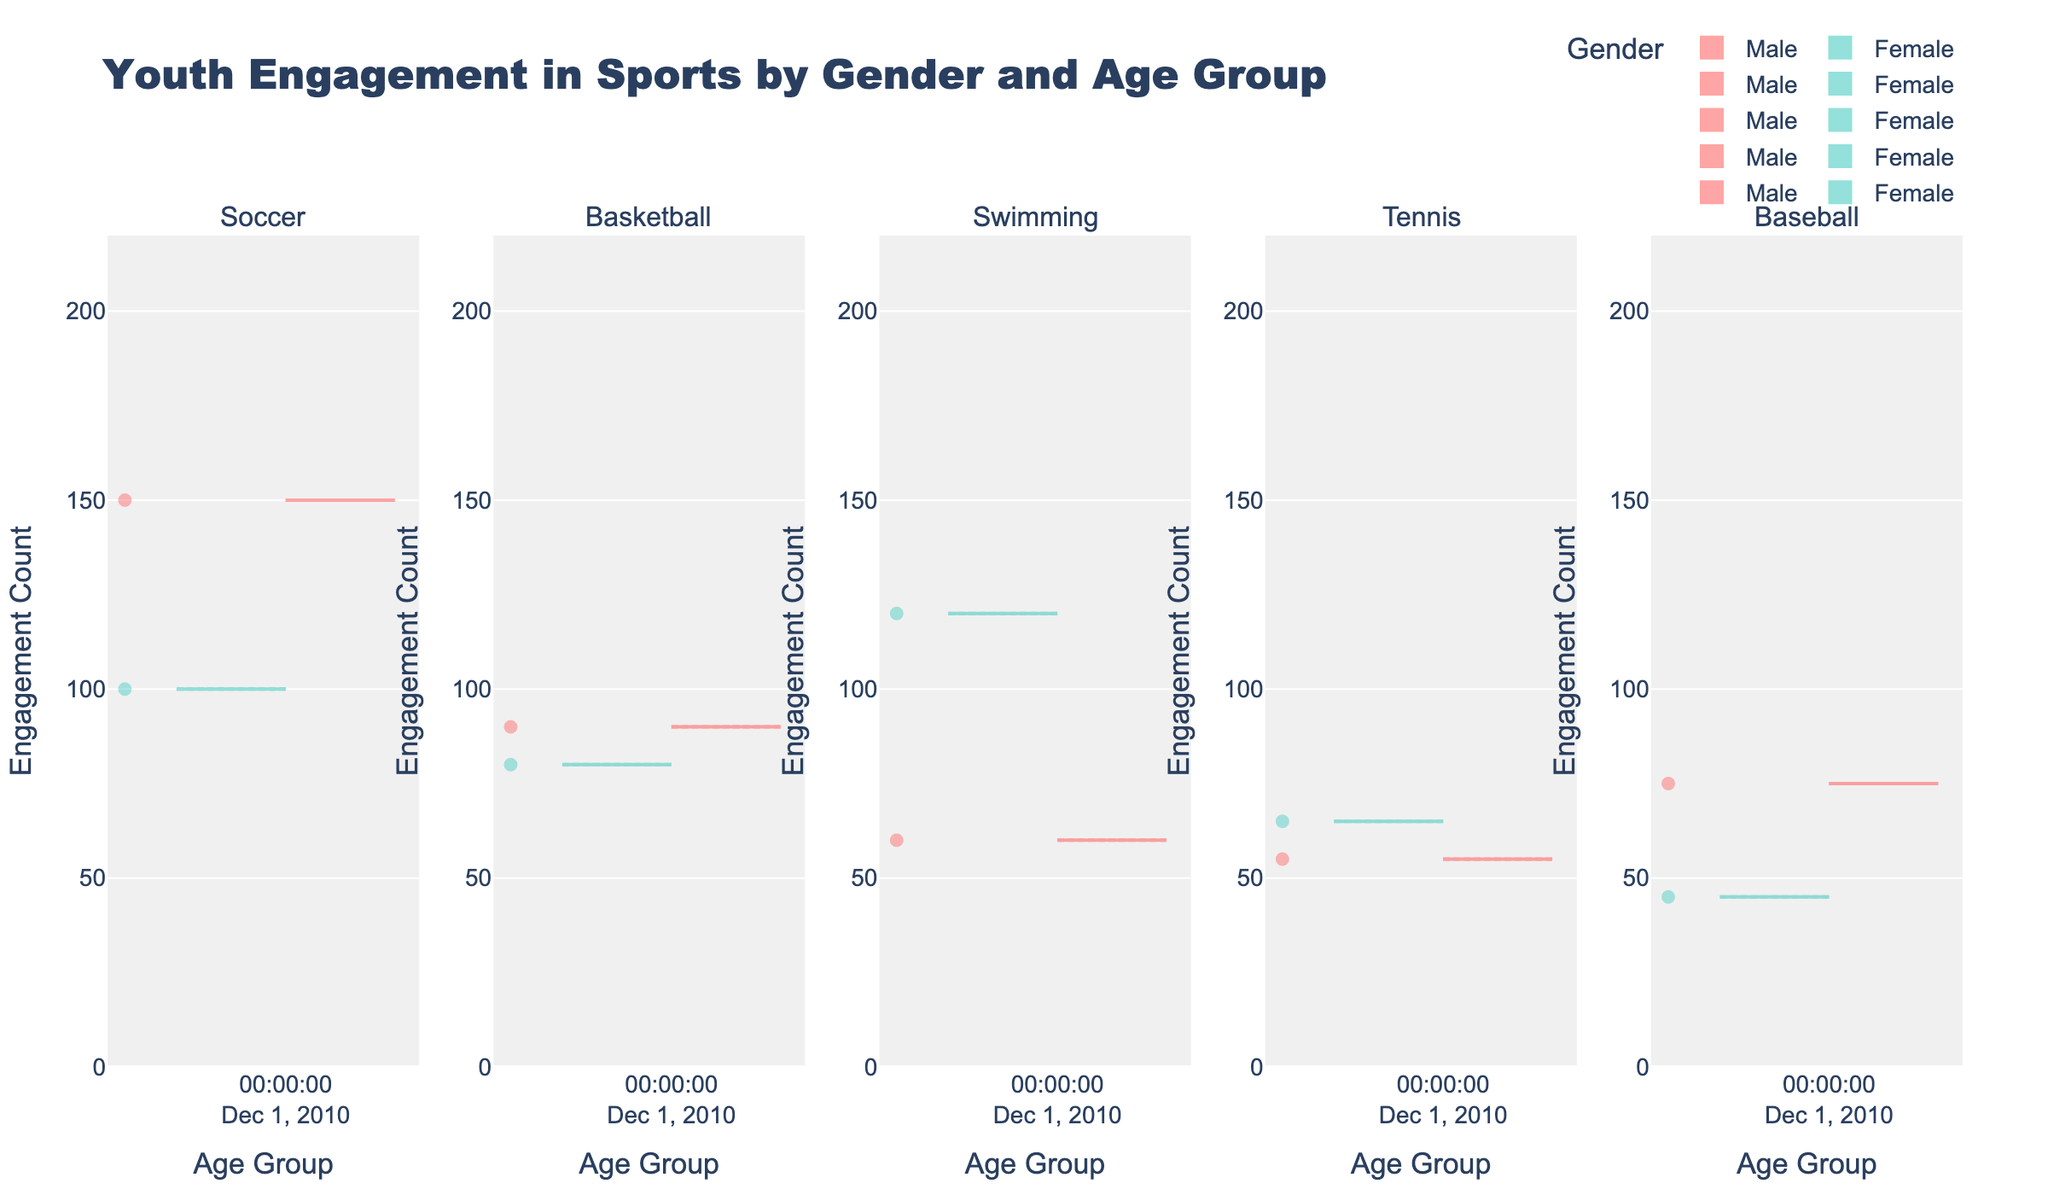What is the title of the figure? The title is usually displayed at the top of the figure in a larger and bolder font compared to other text. In this case, it reads "Youth Engagement in Sports by Gender and Age Group".
Answer: Youth Engagement in Sports by Gender and Age Group How many sports are represented in the subplots? The subplot titles typically display the different sports being represented. By counting the subplot titles, we can determine how many sports are shown.
Answer: 5 For which sport does the female youth engagement seem highest? In violin charts, the height and width of the plot generally indicate the distribution and concentration of data points. The sport that has the widest female-oriented violin plot at its peak tends to represent the highest engagement.
Answer: Swimming Which age group has the highest engagement in Basketball for males? By examining the violin plot for Basketball under the males category, the peak or the thickest part of the violin corresponds to the age group with the highest engagement.
Answer: 13-15 Compare the engagement count in Soccer between males and females in the 13-15 age group. Which gender has higher engagement? Locate the Soccer subplot and identify the violin plots for the 13-15 age group. By comparing the spreads, one can see which gender's plot covers a higher range of engagement counts.
Answer: Male What is the average engagement count for Swimming among the 16-18 age group? For averages, identify the data points represented by the dots on the violin plot for the 16-18 age group in Swimming. Sum the engagement counts and divide by the number of data points (assuming uniform distribution visually).
Answer: 125 Out of the listed age groups, which age group has the lowest engagement in Tennis for females? Examine the violin plots for Tennis and look at the lowest point of engagement across the subplots for the female category, focussing on the starting points of the distributions.
Answer: 10-12 Which sport shows a more balanced gender participation in the 10-12 age group? Balance in participation can be inferred from looking for sports where the male and female violin plots overlap or have similar spread in the 10-12 age group.
Answer: Tennis How does male engagement in Soccer change from 13-15 to 16-18 age group? Track the distribution of the violin plot for males in Soccer across the specified age groups to observe any upward or downward shift or change in thickness.
Answer: Decreases In which sport do we observe the smallest difference in engagement between the 13-15 and 16-18 age groups for females? Look at the violin plots for females in all sports and compare the spread and position for the 13-15 and 16-18 age groups. The sport with minimal shift or overlap indicates a small difference.
Answer: Basketball 